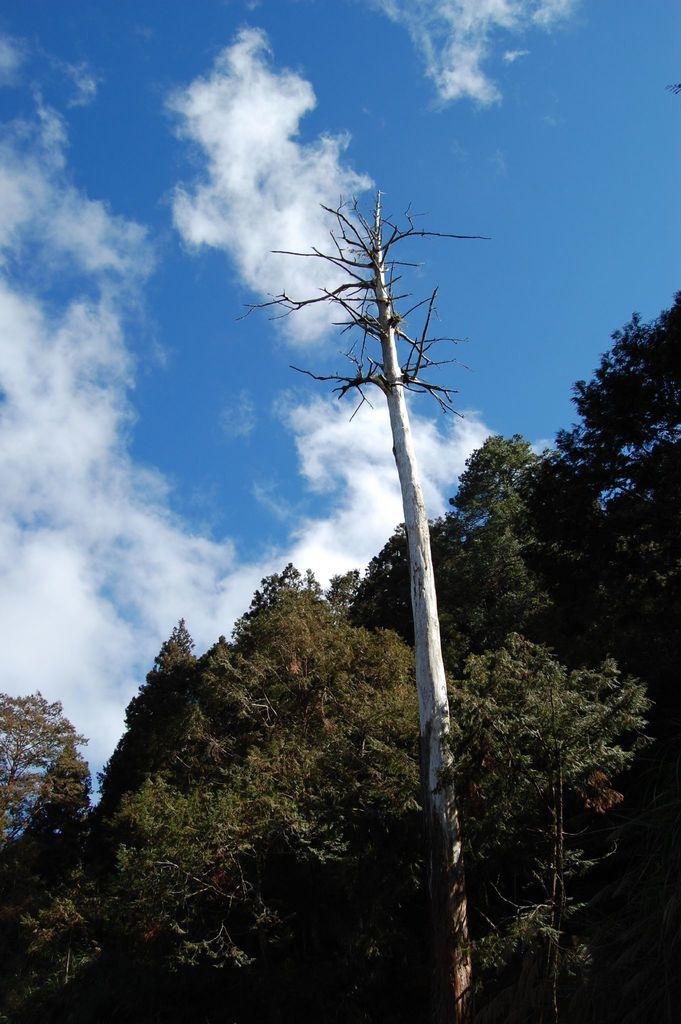What type of vegetation can be seen in the image? There are trees in the image. What part of the natural environment is visible in the image? The sky is visible in the image. How would you describe the sky in the image? The sky appears to be cloudy. What type of pipe is visible in the image? There is no pipe present in the image. How many pages are visible in the image? There are no pages present in the image. 